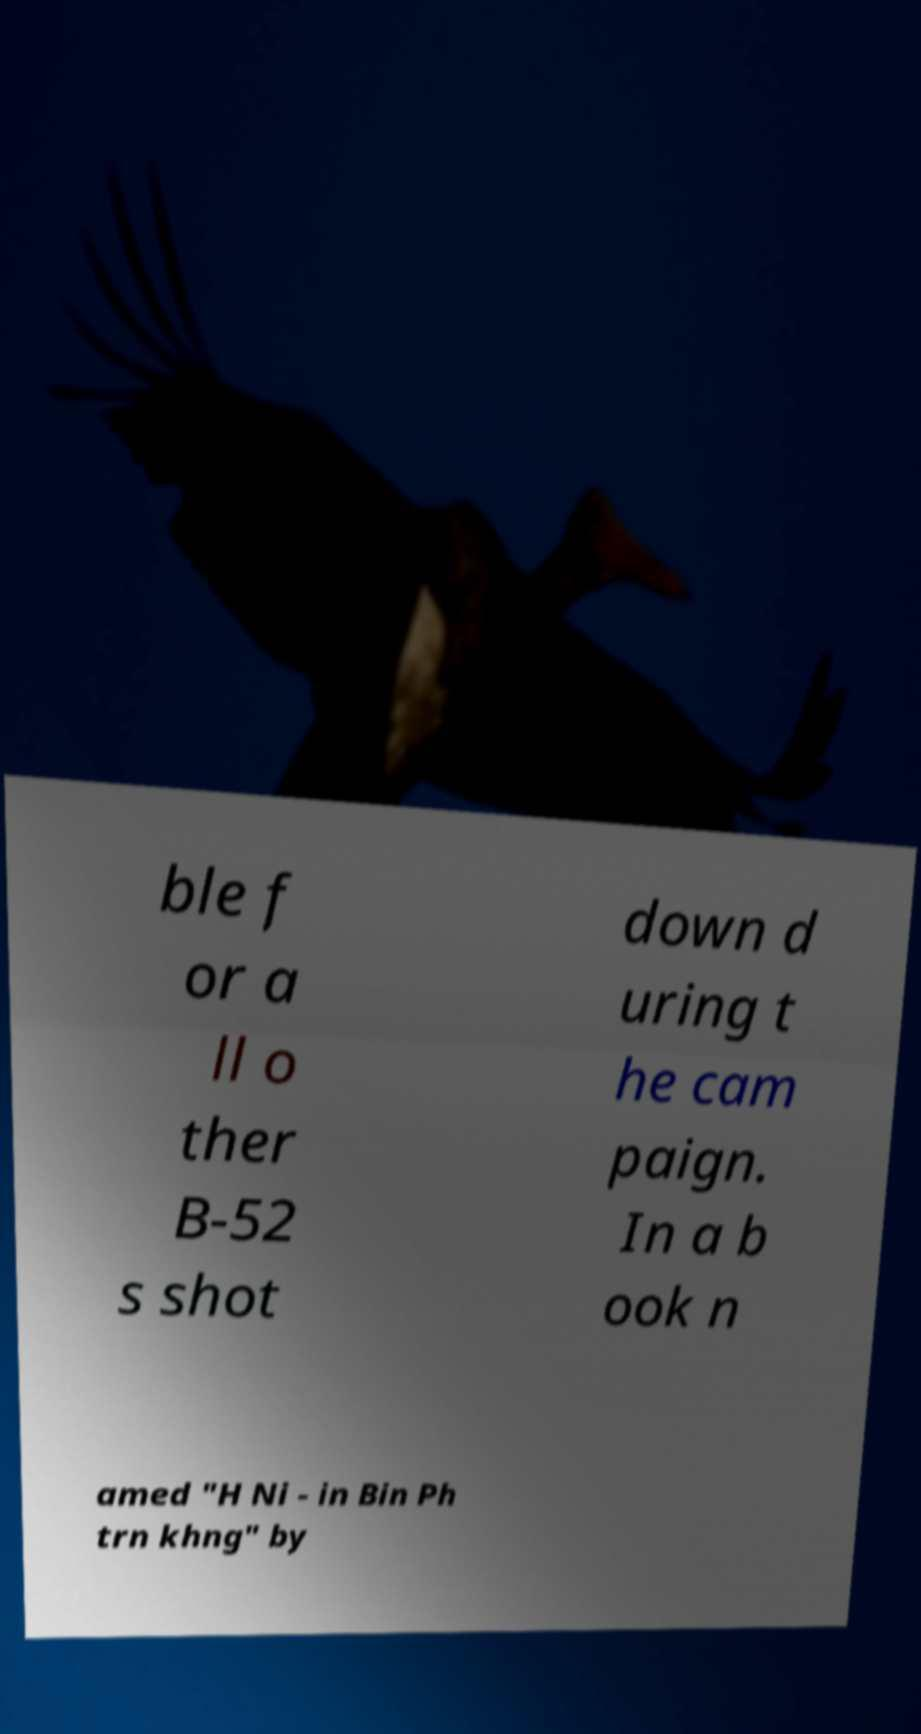Can you read and provide the text displayed in the image?This photo seems to have some interesting text. Can you extract and type it out for me? ble f or a ll o ther B-52 s shot down d uring t he cam paign. In a b ook n amed "H Ni - in Bin Ph trn khng" by 